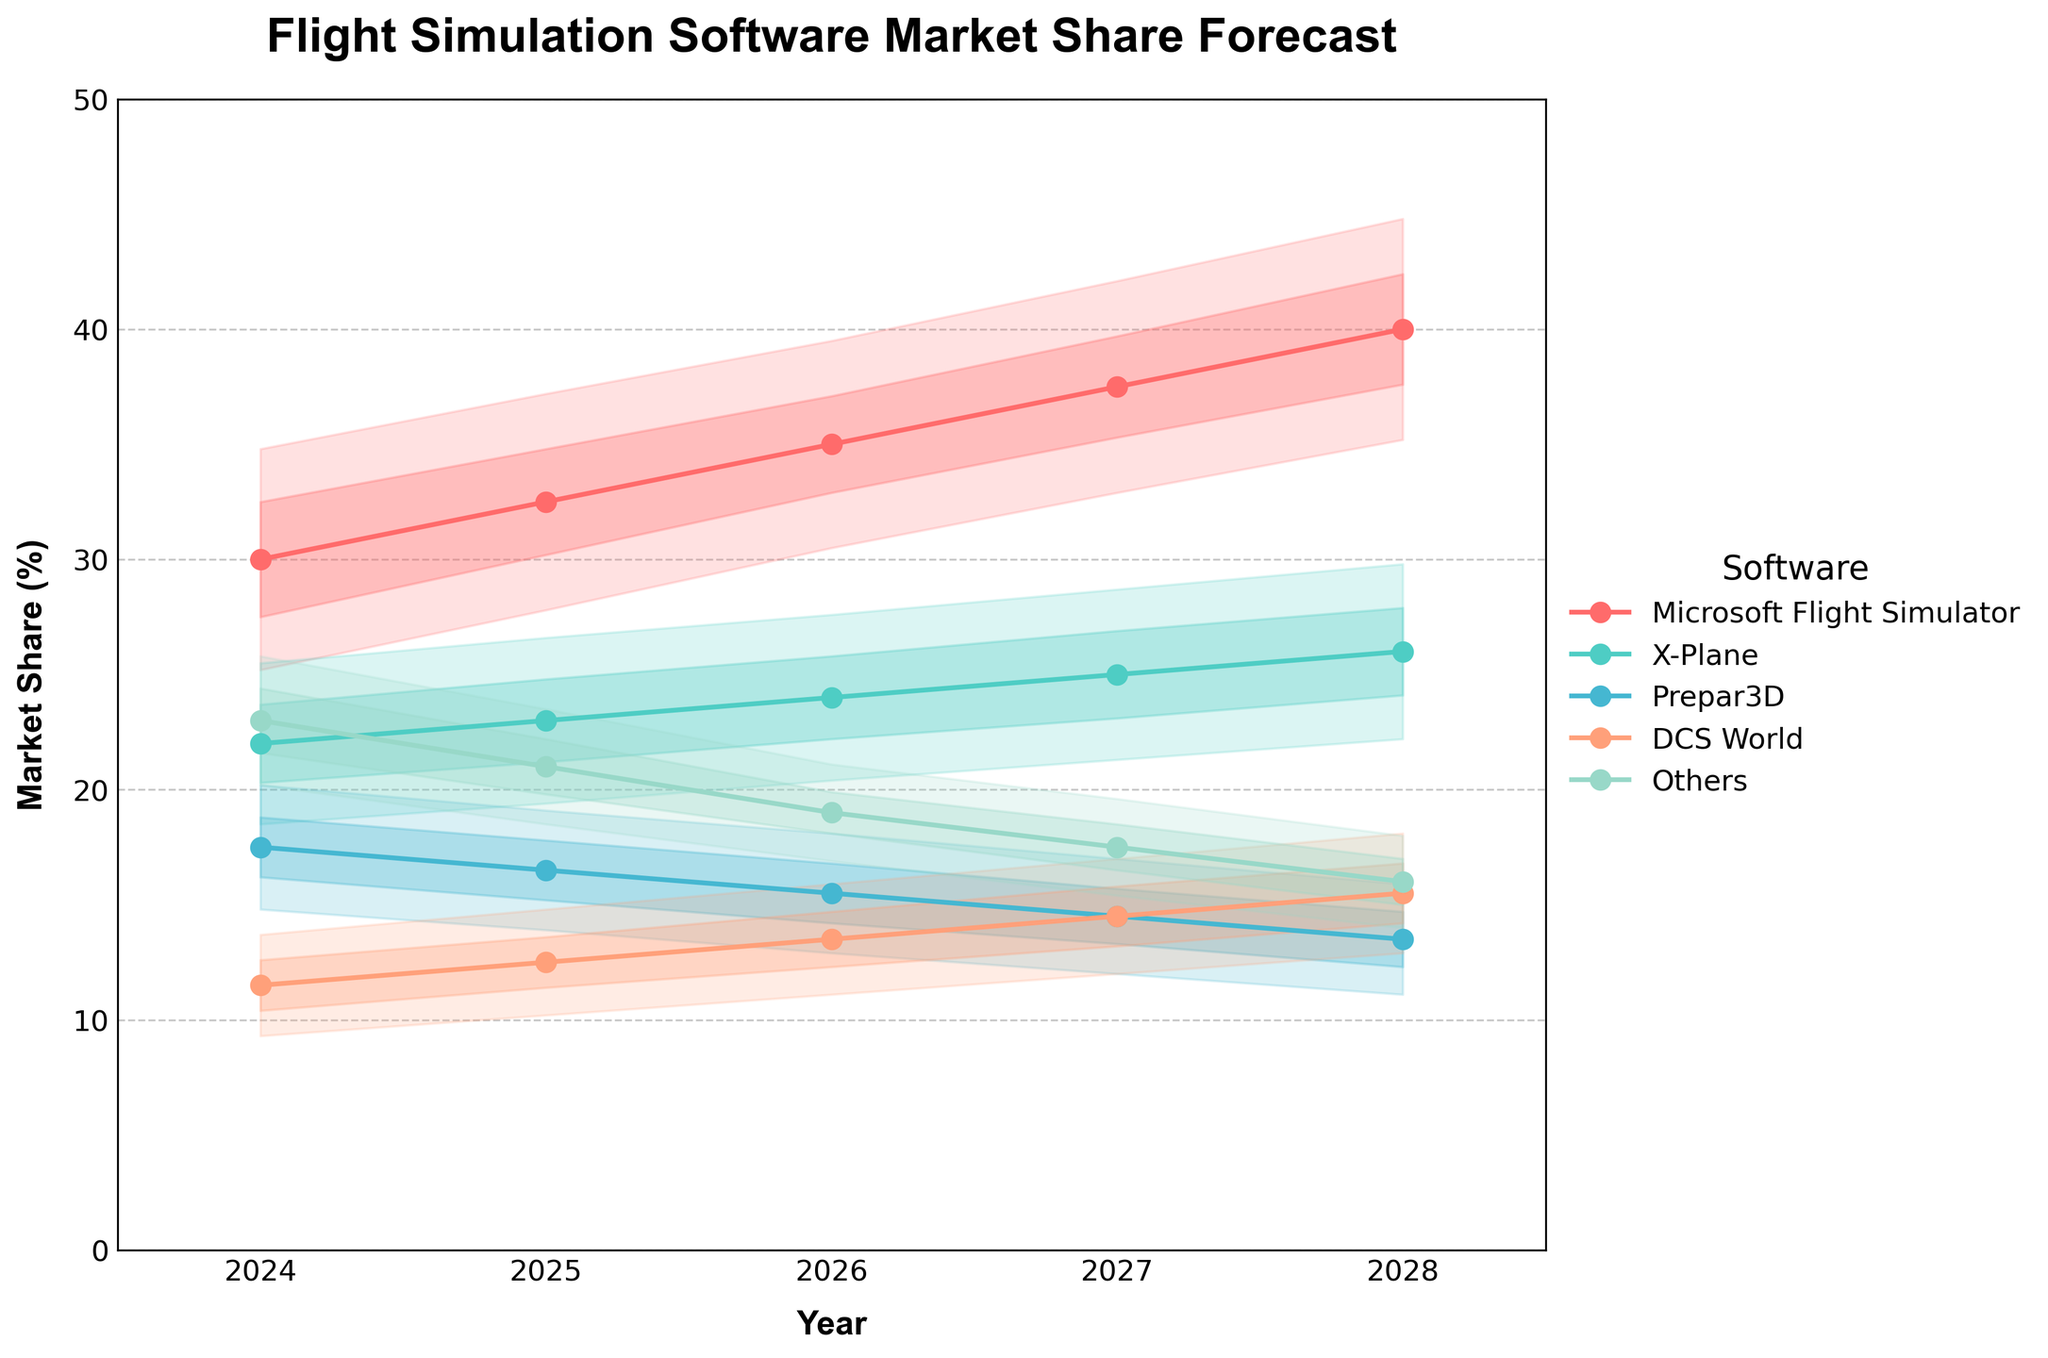What is the market share range (Lower 95% CI to Upper 95% CI) for Microsoft Flight Simulator in 2025? To find the market share range for Microsoft Flight Simulator in 2025, locate the row for the year 2025 and the software "Microsoft Flight Simulator." The range is from the Lower 95% CI to the Upper 95% CI values.
Answer: 27.8 to 37.2 How much is the median market share of Prepar3D expected to decrease from 2024 to 2028? First, find the median market share of Prepar3D for the years 2024 and 2028. For 2024, the median is 17.5, and for 2028, it is 13.5. Then, subtract the 2028 value from the 2024 value.
Answer: 4.0 Which software has the highest upper bound of the 80% confidence interval in 2027? For this, identify the upper 80% CI values for all software in 2027 and compare them. Microsoft Flight Simulator has the highest upper 80% CI at 39.7.
Answer: Microsoft Flight Simulator What is the projected median market share for DCS World in 2026, and how does this compare to its median in 2024? First, find the median market share values for DCS World in 2026 and 2024, which are 13.5 and 11.5, respectively. Then, calculate the difference between these values.
Answer: 13.5, increased by 2.0 Which year does X-Plane's median market share show the largest increase, and by how much? Calculate the yearly differences in the median market share for X-Plane: 2025-2024 (23.0 - 22.0), 2026-2025 (24.0 - 23.0), 2027-2026 (25.0 - 24.0), and 2028-2027 (26.0 - 25.0). The largest increase is 2025-2024, which is 1.0.
Answer: 2025, by 1.0 What trend is observed in the 80% confidence interval of "Others" from 2024 to 2028? Compare the lower and upper bounds of the 80% confidence interval for "Others" across the years 2024 to 2028. The 80% CI shows a decreasing trend both in its upper and lower limits.
Answer: Decreasing trend Does Prepar3D ever have a median market share higher than DCS World from 2024 to 2028? Compare the median market share of Prepar3D and DCS World for each year from 2024 to 2028. Prepar3D's median value is consistently greater than that of DCS World each year.
Answer: Yes What is the percentage range of X-Plane's market share in 2028 based on the 80% confidence interval? Locate the lower and upper 80% CI values for X-Plane in 2028. These values are 24.1 and 27.9, respectively.
Answer: 24.1 to 27.9 How does the upper 95% confidence interval for Microsoft Flight Simulator in 2024 compare to its upper 95% CI in 2028? Identify the upper 95% CI values for Microsoft Flight Simulator in 2024 and 2028, which are 34.8 and 44.8, respectively. Then calculate the difference.
Answer: Increased by 10.0 